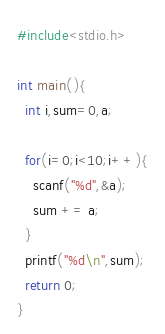<code> <loc_0><loc_0><loc_500><loc_500><_C_>#include<stdio.h>

int main(){
  int i,sum=0,a;

  for(i=0;i<10;i++){
    scanf("%d",&a);
    sum += a;
  }
  printf("%d\n",sum);
  return 0;
}

</code> 